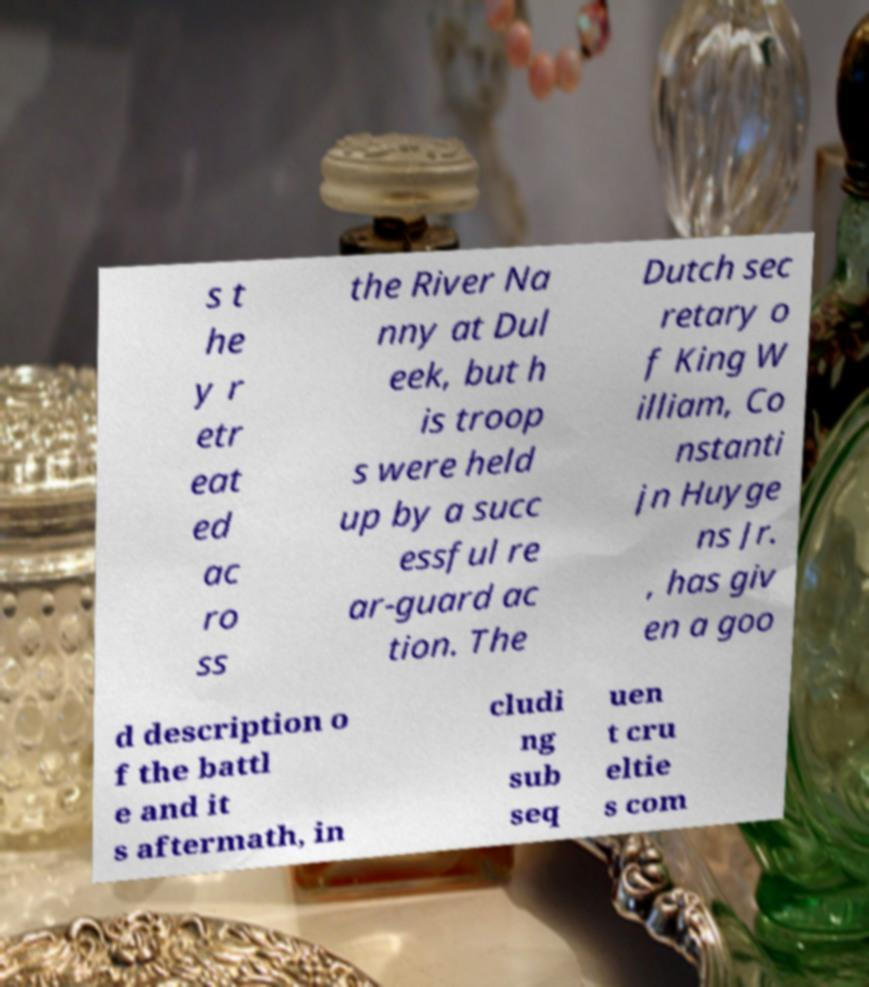Can you read and provide the text displayed in the image?This photo seems to have some interesting text. Can you extract and type it out for me? s t he y r etr eat ed ac ro ss the River Na nny at Dul eek, but h is troop s were held up by a succ essful re ar-guard ac tion. The Dutch sec retary o f King W illiam, Co nstanti jn Huyge ns Jr. , has giv en a goo d description o f the battl e and it s aftermath, in cludi ng sub seq uen t cru eltie s com 